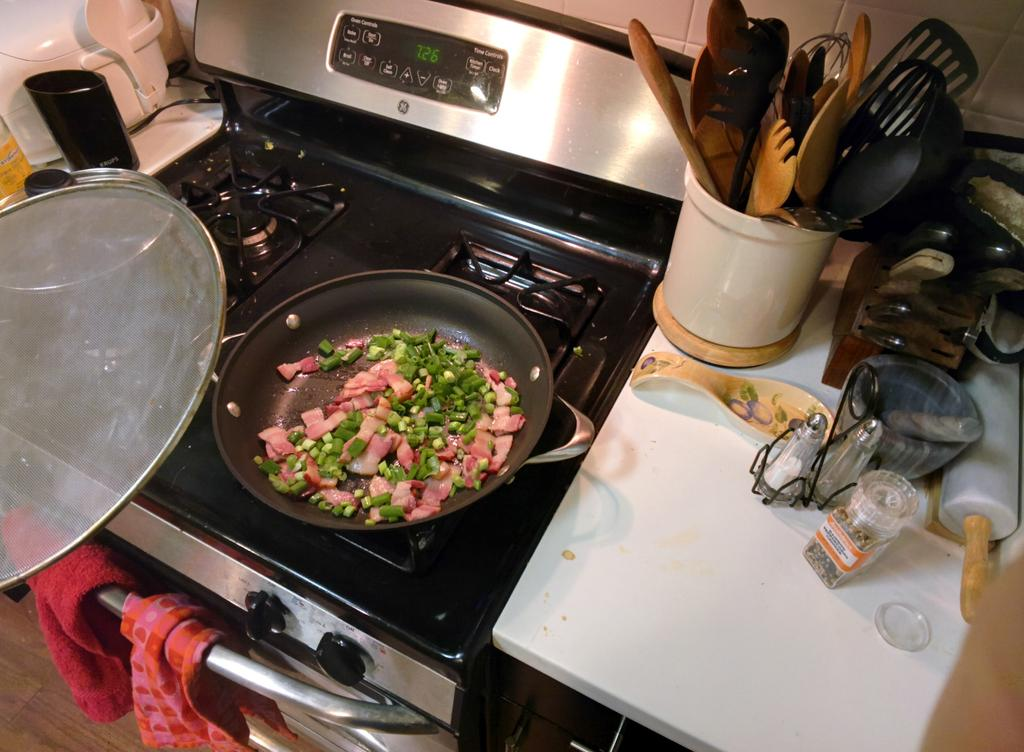<image>
Provide a brief description of the given image. Cut up ham and scallons cooking in a pay on the stove. 